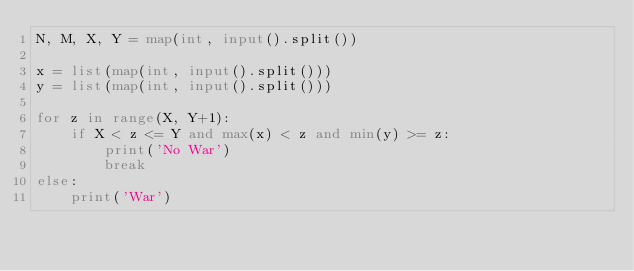<code> <loc_0><loc_0><loc_500><loc_500><_Python_>N, M, X, Y = map(int, input().split())

x = list(map(int, input().split()))
y = list(map(int, input().split()))

for z in range(X, Y+1):
    if X < z <= Y and max(x) < z and min(y) >= z:
        print('No War')
        break
else:
    print('War')</code> 